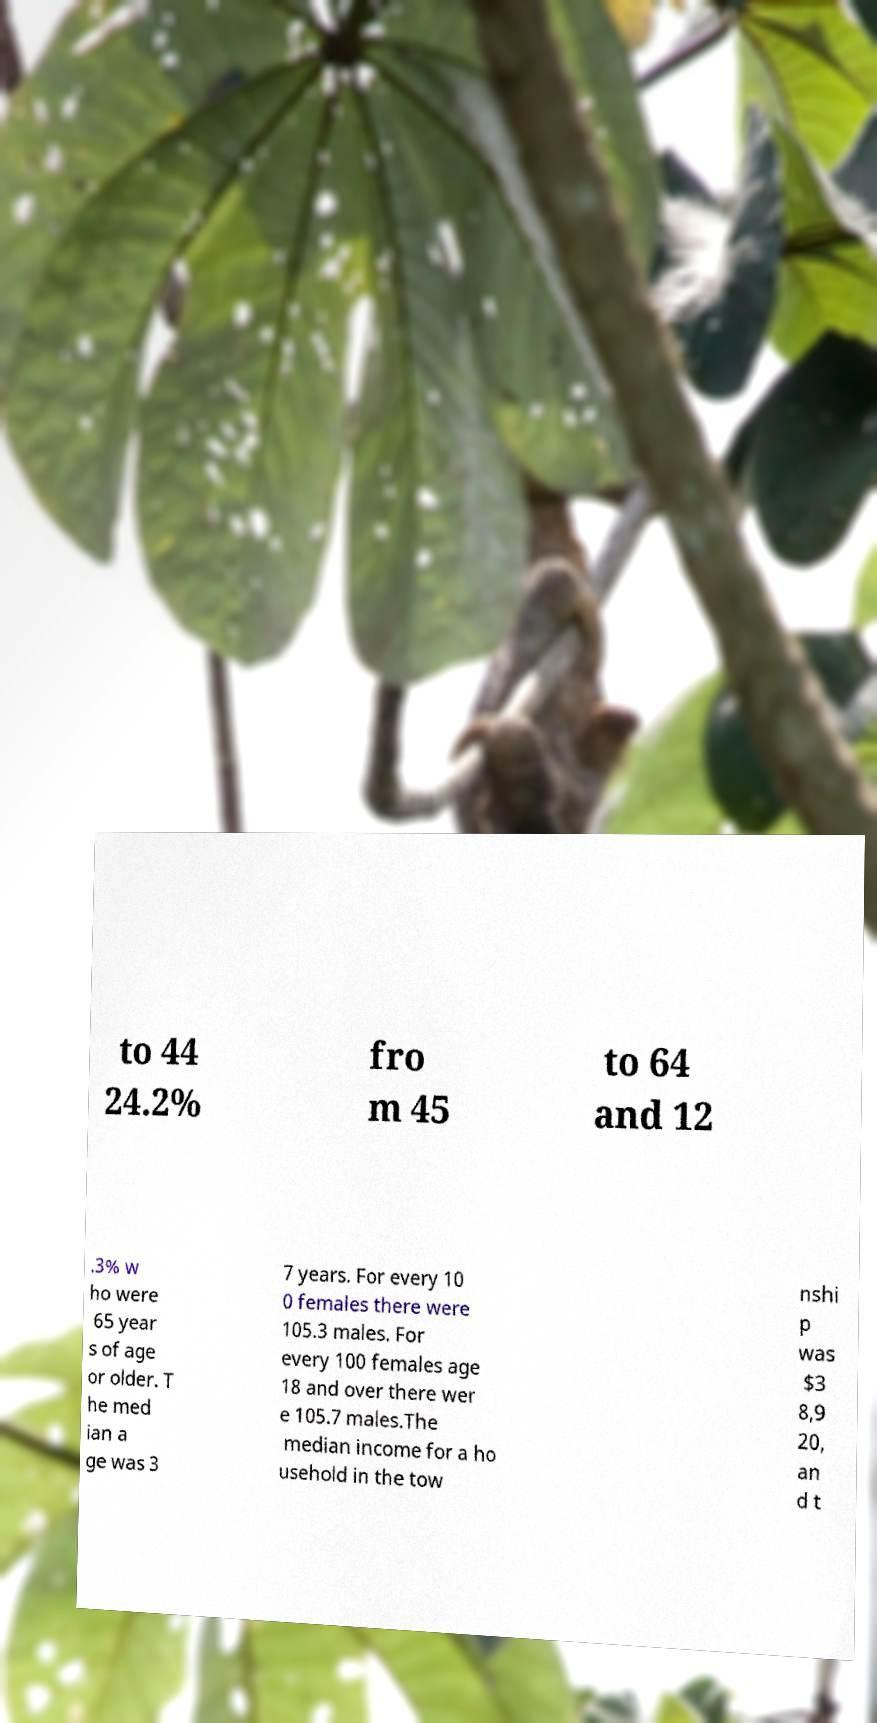There's text embedded in this image that I need extracted. Can you transcribe it verbatim? to 44 24.2% fro m 45 to 64 and 12 .3% w ho were 65 year s of age or older. T he med ian a ge was 3 7 years. For every 10 0 females there were 105.3 males. For every 100 females age 18 and over there wer e 105.7 males.The median income for a ho usehold in the tow nshi p was $3 8,9 20, an d t 